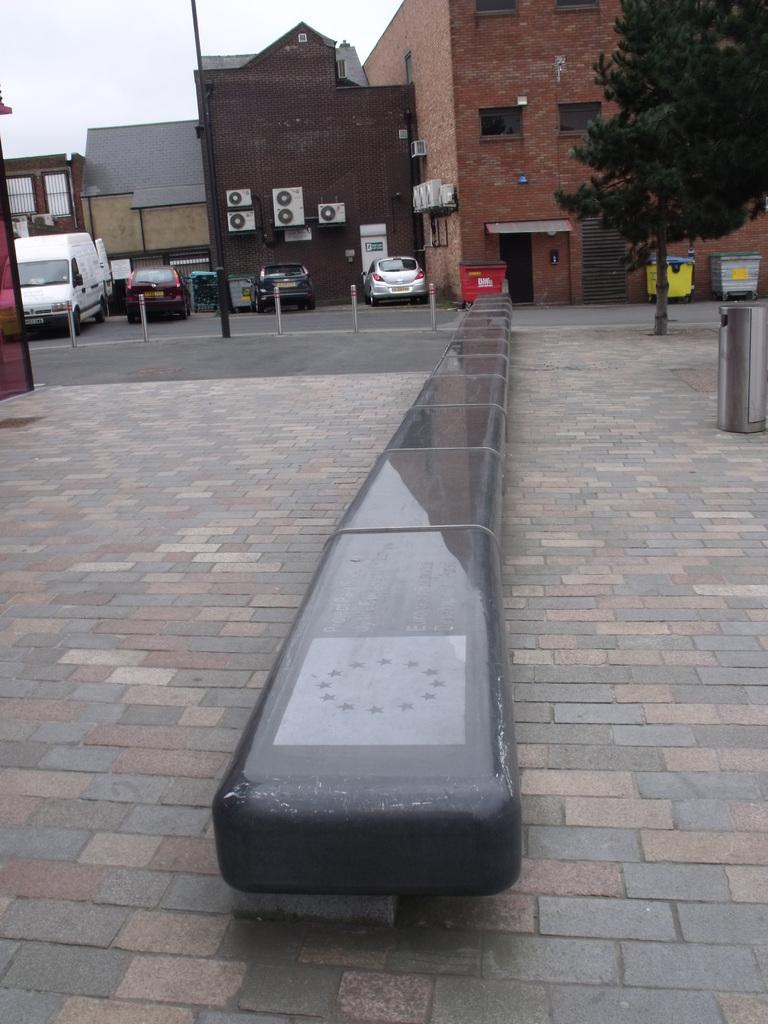What is the main subject in the middle of the image? There is a walkway stone in the middle of the image. What can be seen in the background of the image? There are vehicles and buildings in the background of the image. What type of vegetation is on the right side of the image? There is a tree on the right side of the image. What is visible at the top of the image? The sky is visible at the top of the image. What time is displayed on the clock in the image? There is no clock present in the image. What type of food is being served for lunch in the image? There is no mention of lunch or food in the image. 